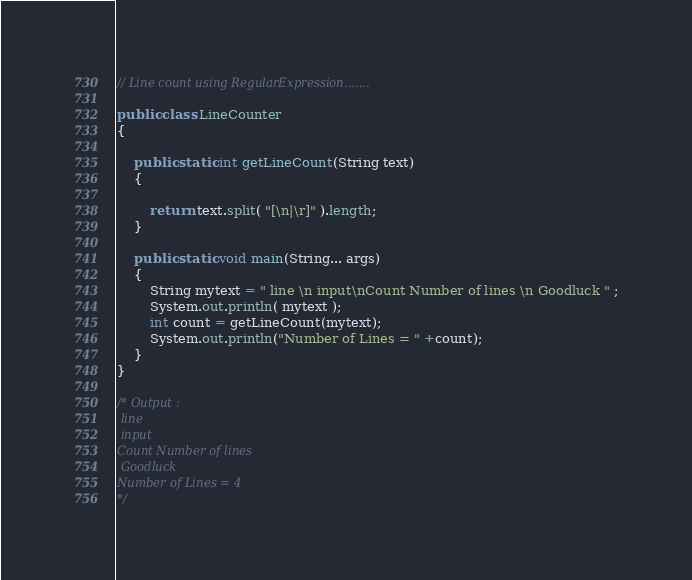Convert code to text. <code><loc_0><loc_0><loc_500><loc_500><_Java_>// Line count using RegularExpression.......

public class LineCounter 
{

	public static int getLineCount(String text)
	{
		
		return text.split( "[\n|\r]" ).length;
	}
	
	public static void main(String... args)
	{
		String mytext = " line \n input\nCount Number of lines \n Goodluck " ;
		System.out.println( mytext );
		int count = getLineCount(mytext);
		System.out.println("Number of Lines = " +count);
	}
}

/* Output :
 line
 input
Count Number of lines
 Goodluck
Number of Lines = 4 
*/</code> 